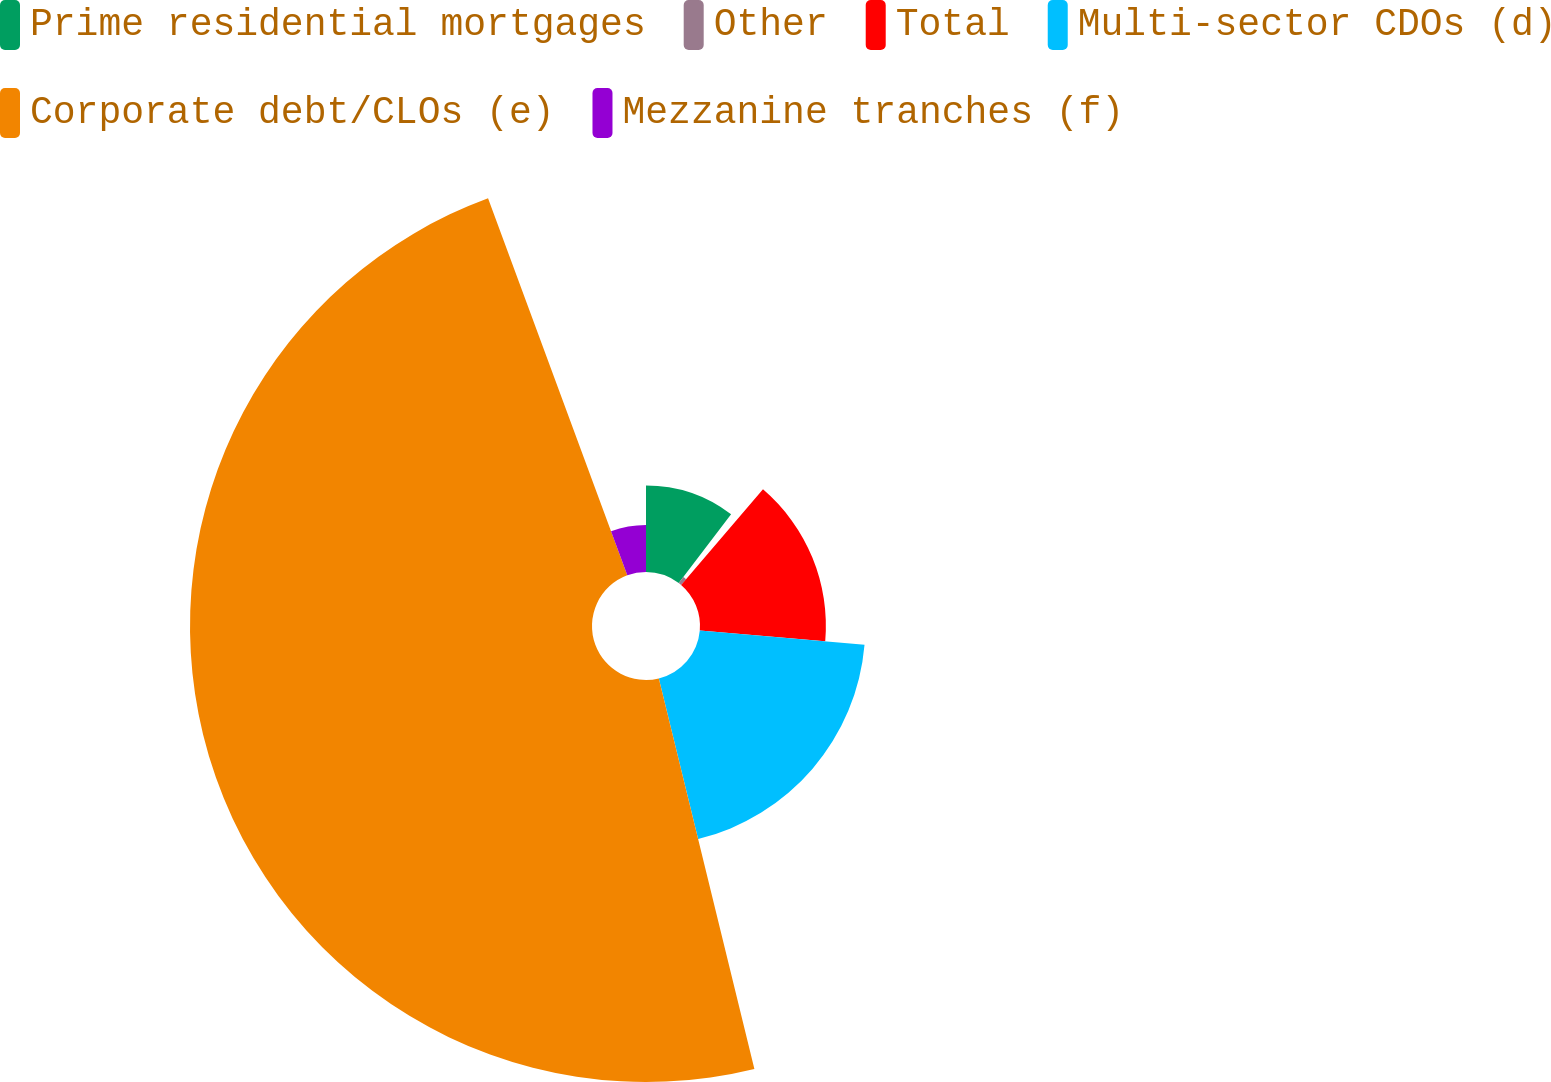Convert chart. <chart><loc_0><loc_0><loc_500><loc_500><pie_chart><fcel>Prime residential mortgages<fcel>Other<fcel>Total<fcel>Multi-sector CDOs (d)<fcel>Corporate debt/CLOs (e)<fcel>Mezzanine tranches (f)<nl><fcel>10.36%<fcel>0.91%<fcel>15.09%<fcel>19.82%<fcel>48.19%<fcel>5.63%<nl></chart> 